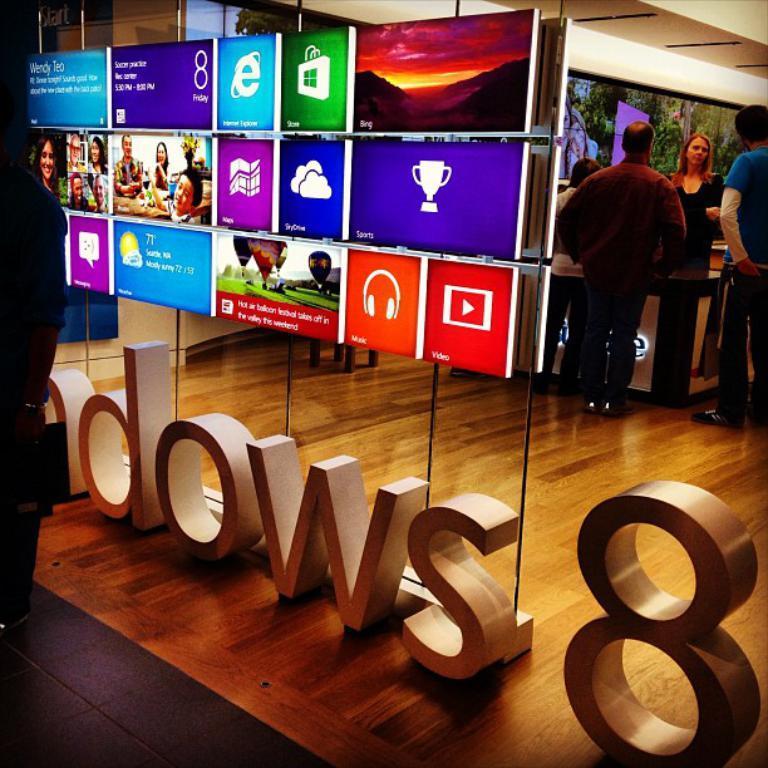Could you give a brief overview of what you see in this image? This picture shows few people standing in the store and we see advertisement screens and we see a man standing on the side. 